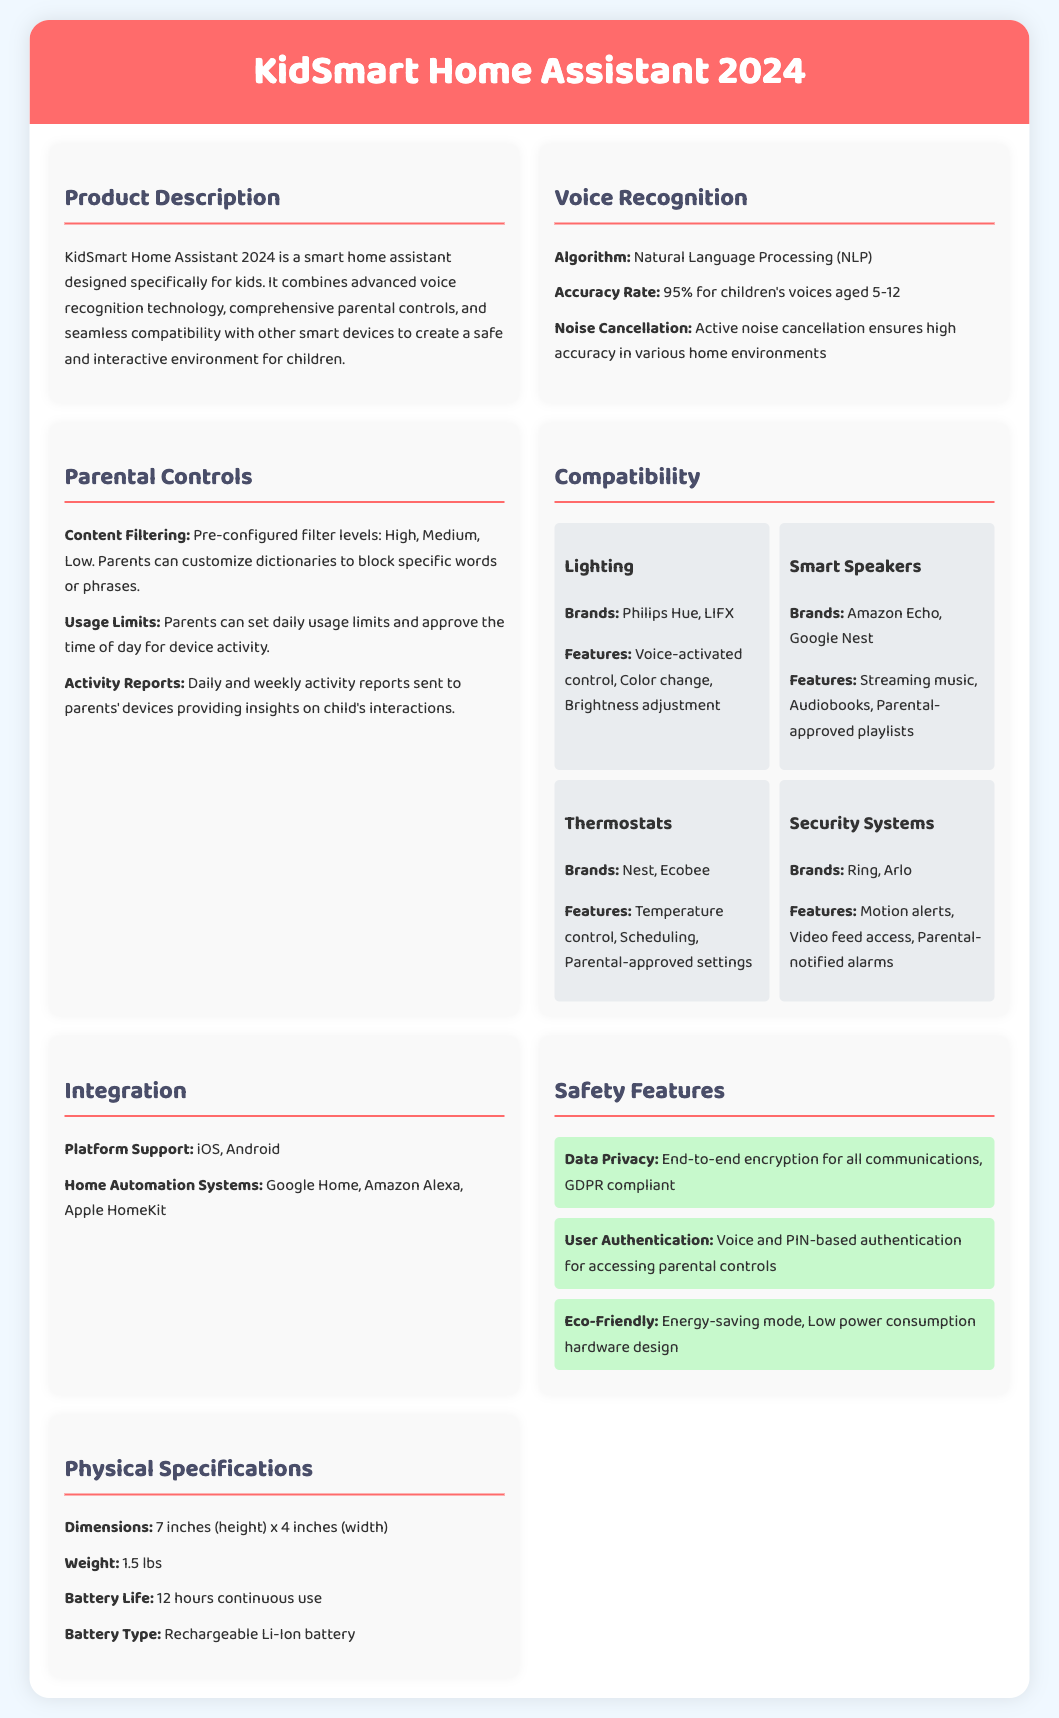What is the accuracy rate for voice recognition? The accuracy rate for voice recognition is stated specifically for children's voices aged 5-12 in the document.
Answer: 95% What are the parental control features? The document lists specific features about parental controls, including content filtering and usage limits.
Answer: Content filtering, usage limits, and activity reports Which smart speaker brands are compatible? The document details the brands of smart speakers that are compatible with the KidSmart Home Assistant.
Answer: Amazon Echo, Google Nest What type of battery is used? The product specification sheet mentions the type of battery that powers the device.
Answer: Rechargeable Li-Ion battery What is the height of the device? The physical specifications section of the document provides dimensions, including height.
Answer: 7 inches What feature ensures high accuracy in noisy environments? The document explains a specific feature that improves voice recognition in various home environments.
Answer: Active noise cancellation What are the pre-configured filter levels for content filtering? The document describes how parents can customize the content filtering but also gives the standard levels.
Answer: High, Medium, Low Which home automation systems does the device support? The specification sheet lists the platforms that the KidSmart Home Assistant is compatible with.
Answer: Google Home, Amazon Alexa, Apple HomeKit 